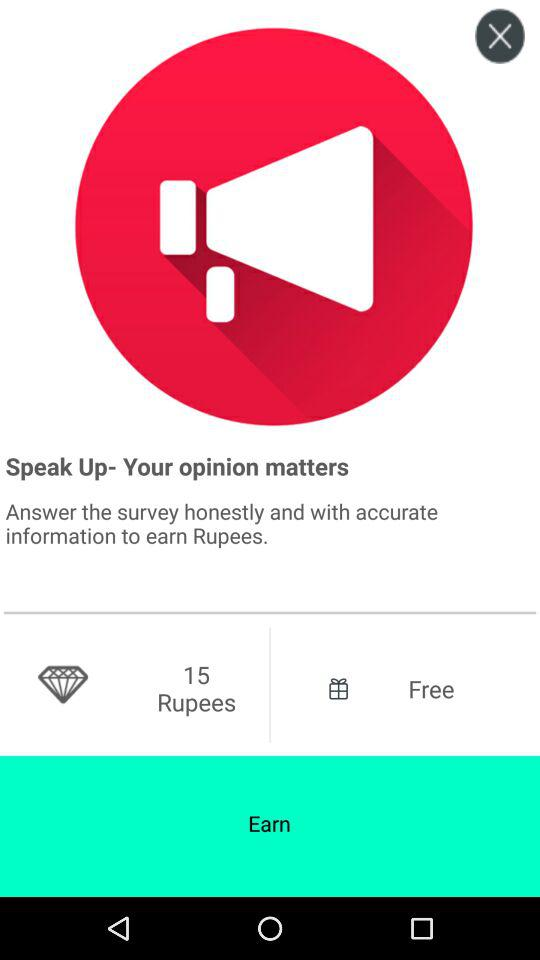How many rupees are shown on the screen? The shown rupees are 15. 